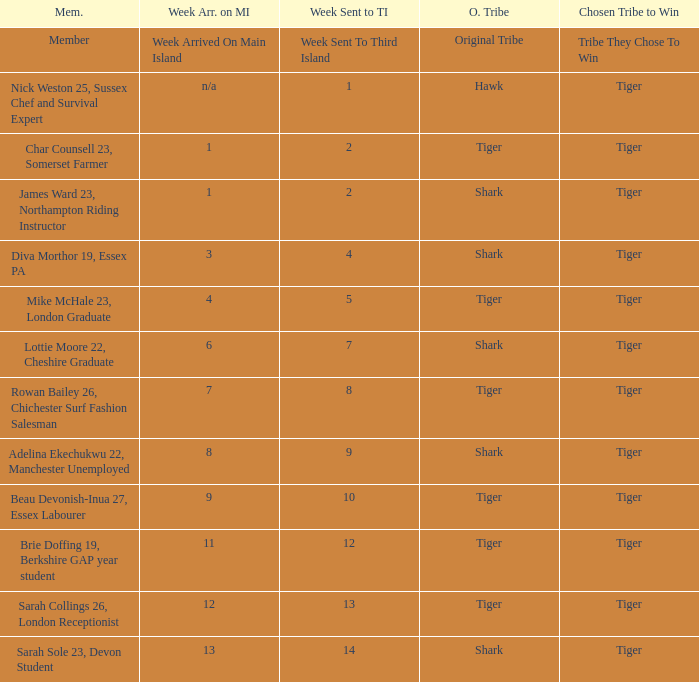Who was sent to the third island in week 1? Nick Weston 25, Sussex Chef and Survival Expert. 